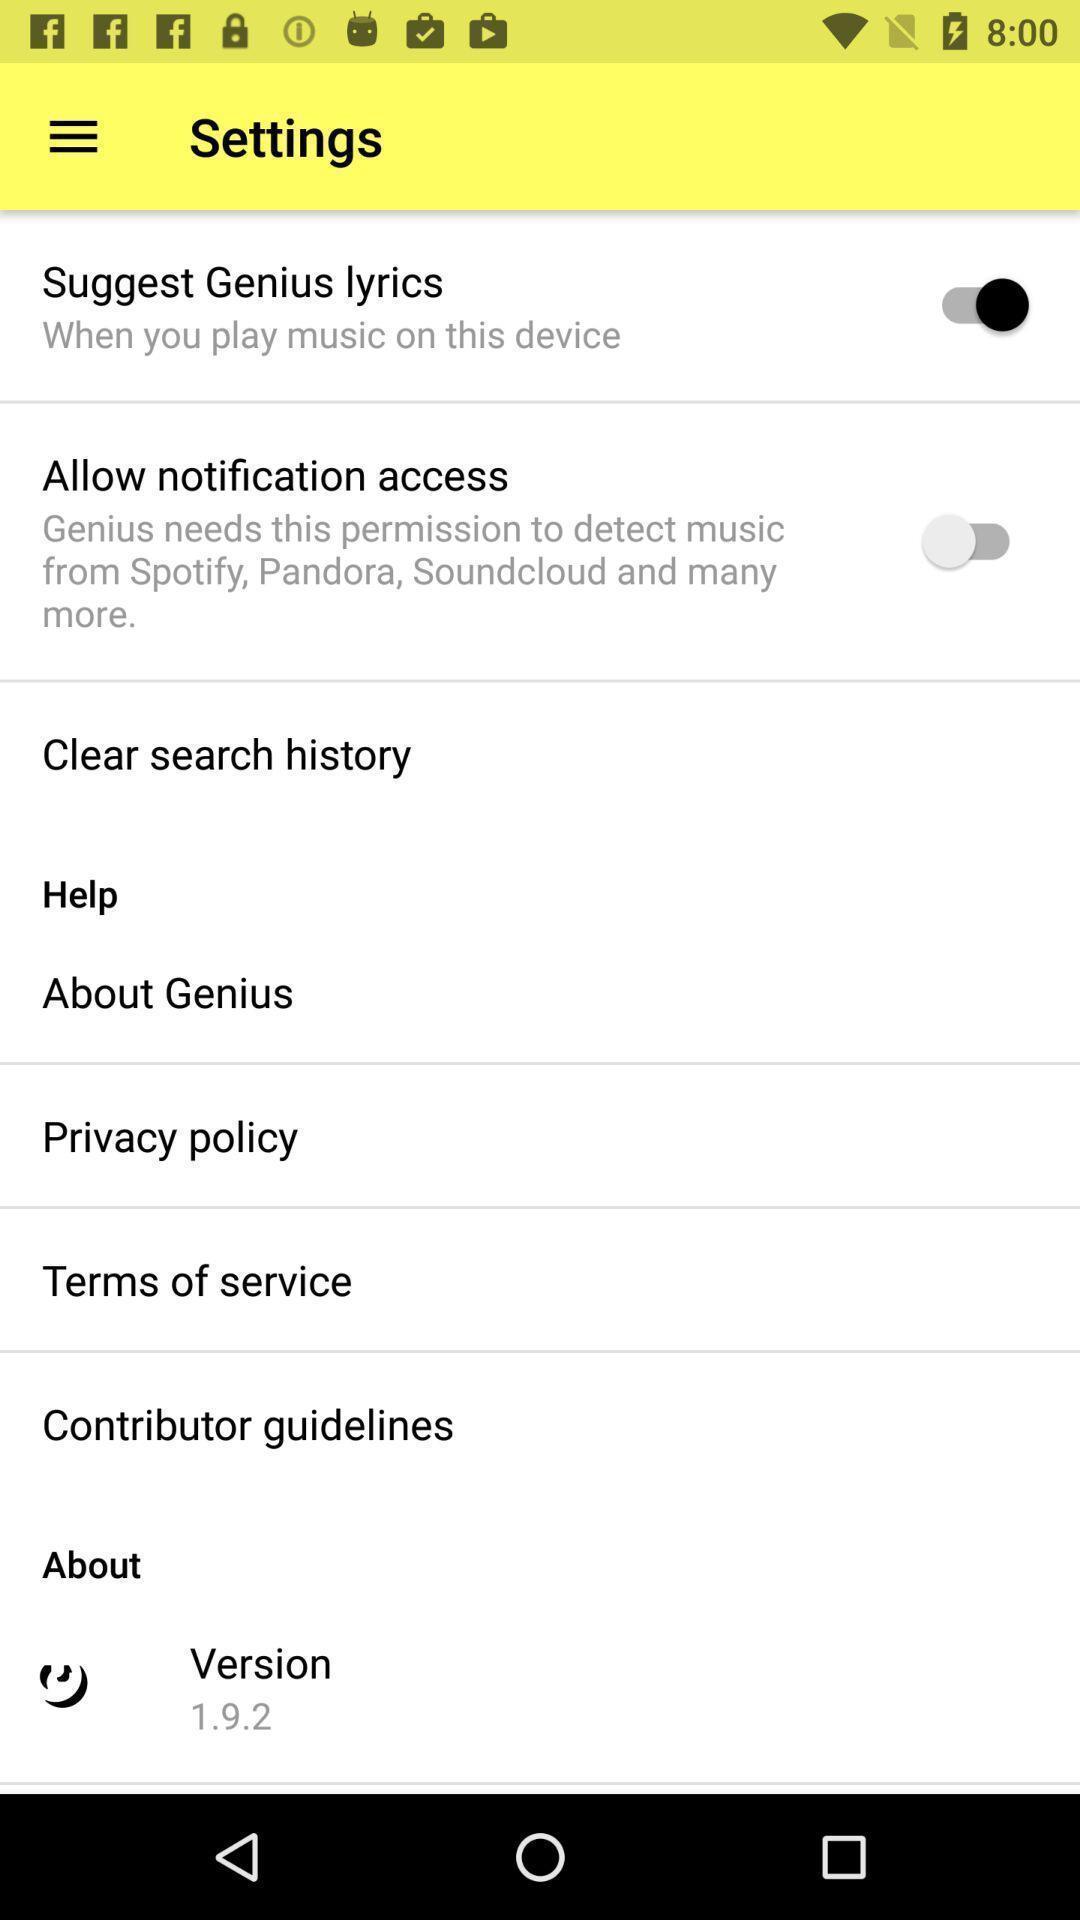Summarize the main components in this picture. Setting page displaying the various options. 